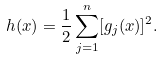Convert formula to latex. <formula><loc_0><loc_0><loc_500><loc_500>h ( x ) = \frac { 1 } { 2 } \sum _ { j = 1 } ^ { n } [ g _ { j } ( x ) ] ^ { 2 } .</formula> 